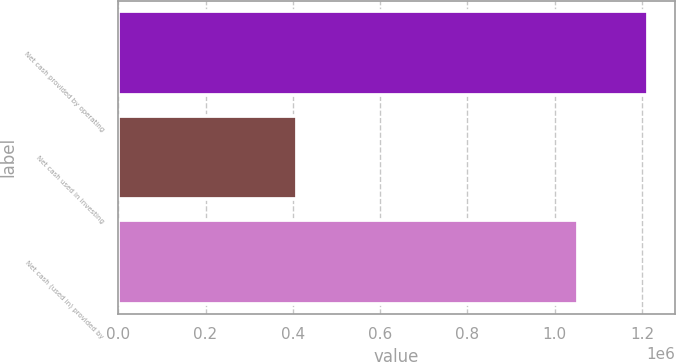Convert chart to OTSL. <chart><loc_0><loc_0><loc_500><loc_500><bar_chart><fcel>Net cash provided by operating<fcel>Net cash used in investing<fcel>Net cash (used in) provided by<nl><fcel>1.21413e+06<fcel>410617<fcel>1.05426e+06<nl></chart> 